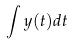Convert formula to latex. <formula><loc_0><loc_0><loc_500><loc_500>\int y ( t ) d t</formula> 